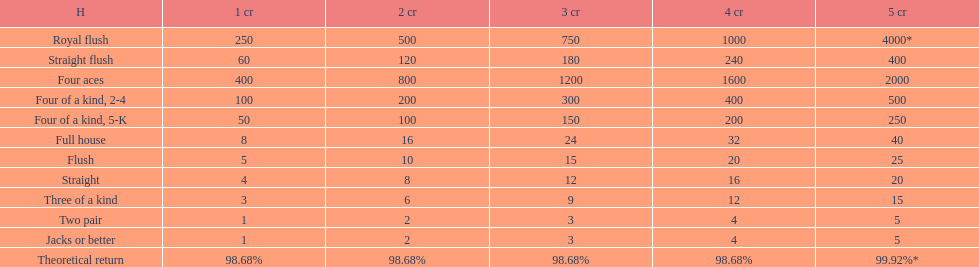What is the difference of payout on 3 credits, between a straight flush and royal flush? 570. Give me the full table as a dictionary. {'header': ['H', '1 cr', '2 cr', '3 cr', '4 cr', '5 cr'], 'rows': [['Royal flush', '250', '500', '750', '1000', '4000*'], ['Straight flush', '60', '120', '180', '240', '400'], ['Four aces', '400', '800', '1200', '1600', '2000'], ['Four of a kind, 2-4', '100', '200', '300', '400', '500'], ['Four of a kind, 5-K', '50', '100', '150', '200', '250'], ['Full house', '8', '16', '24', '32', '40'], ['Flush', '5', '10', '15', '20', '25'], ['Straight', '4', '8', '12', '16', '20'], ['Three of a kind', '3', '6', '9', '12', '15'], ['Two pair', '1', '2', '3', '4', '5'], ['Jacks or better', '1', '2', '3', '4', '5'], ['Theoretical return', '98.68%', '98.68%', '98.68%', '98.68%', '99.92%*']]} 